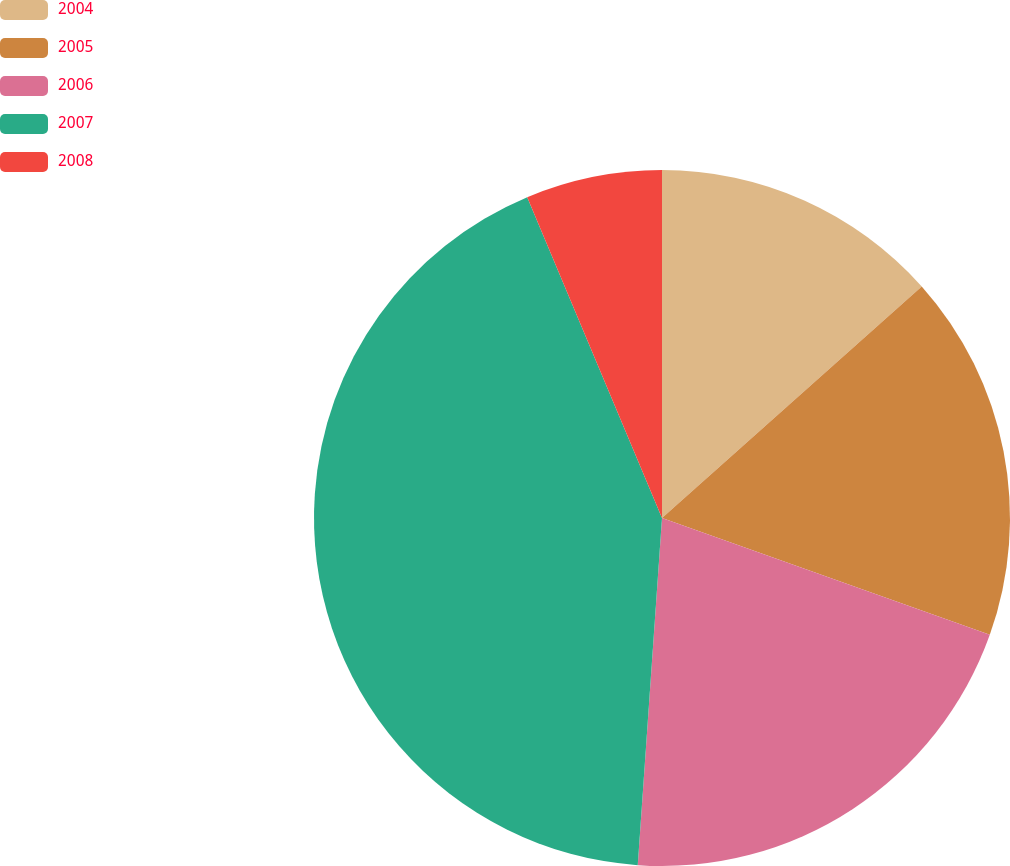Convert chart to OTSL. <chart><loc_0><loc_0><loc_500><loc_500><pie_chart><fcel>2004<fcel>2005<fcel>2006<fcel>2007<fcel>2008<nl><fcel>13.41%<fcel>17.04%<fcel>20.66%<fcel>42.56%<fcel>6.33%<nl></chart> 